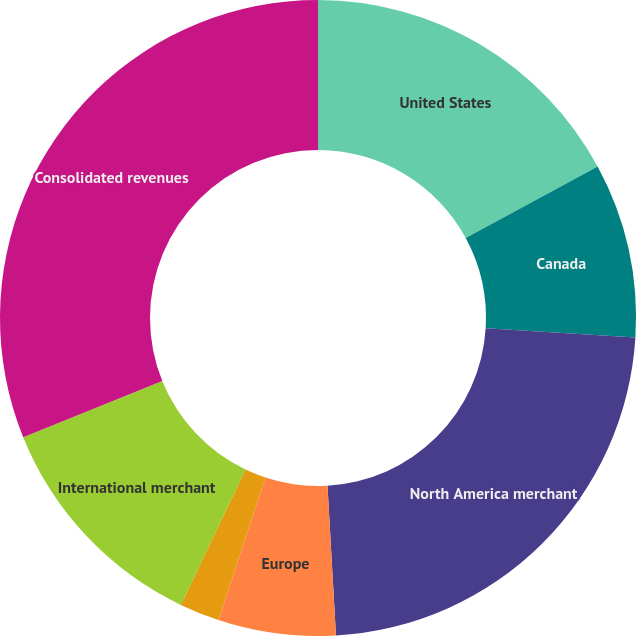Convert chart. <chart><loc_0><loc_0><loc_500><loc_500><pie_chart><fcel>United States<fcel>Canada<fcel>North America merchant<fcel>Europe<fcel>Asia-Pacific<fcel>International merchant<fcel>Consolidated revenues<nl><fcel>17.1%<fcel>8.88%<fcel>23.12%<fcel>5.97%<fcel>2.03%<fcel>11.78%<fcel>31.12%<nl></chart> 